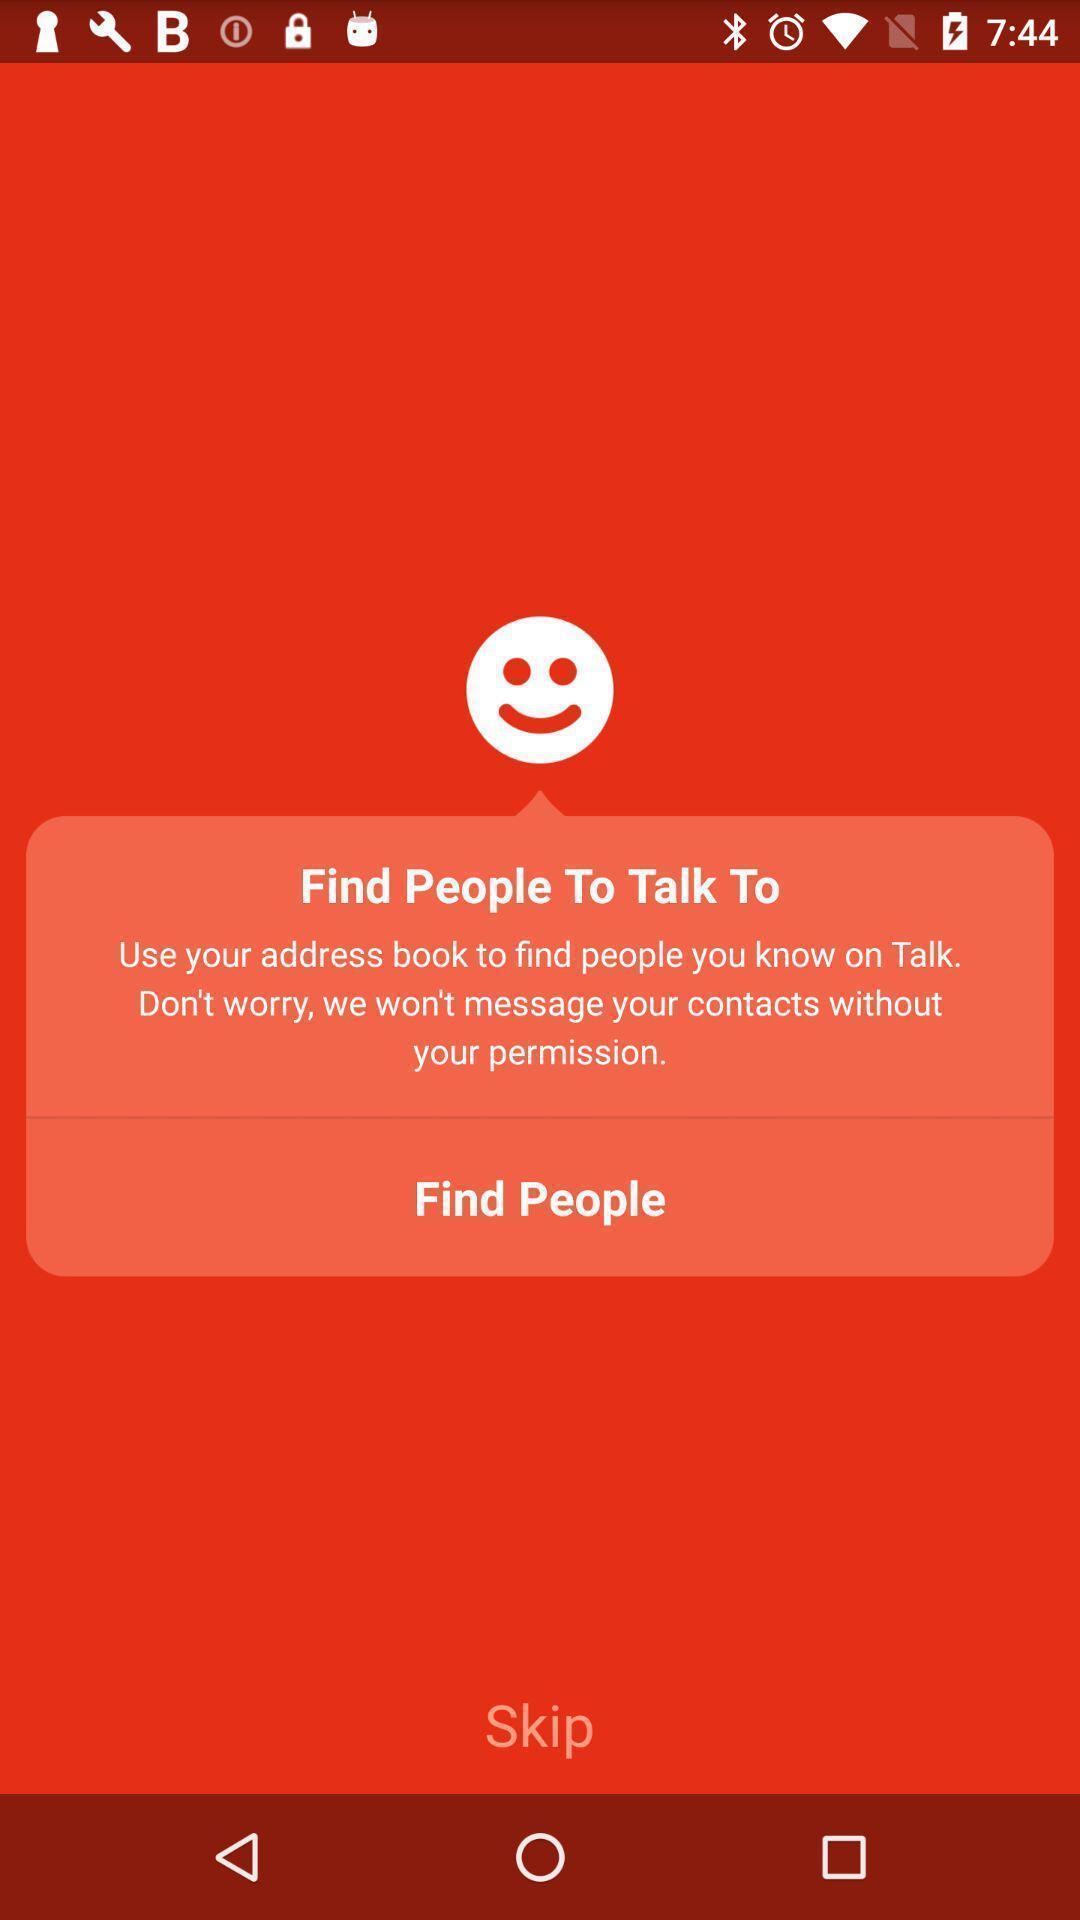Give me a narrative description of this picture. Pop-up displays to find people in app. 